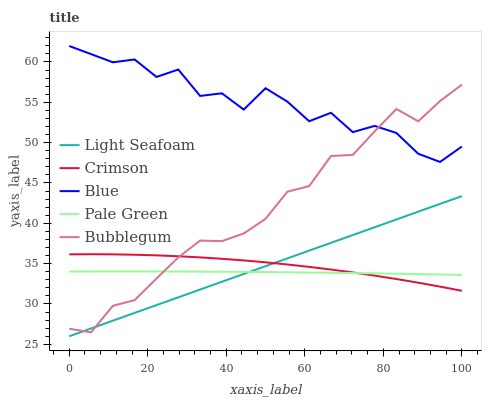Does Blue have the minimum area under the curve?
Answer yes or no. No. Does Pale Green have the maximum area under the curve?
Answer yes or no. No. Is Pale Green the smoothest?
Answer yes or no. No. Is Pale Green the roughest?
Answer yes or no. No. Does Pale Green have the lowest value?
Answer yes or no. No. Does Pale Green have the highest value?
Answer yes or no. No. Is Light Seafoam less than Blue?
Answer yes or no. Yes. Is Blue greater than Pale Green?
Answer yes or no. Yes. Does Light Seafoam intersect Blue?
Answer yes or no. No. 